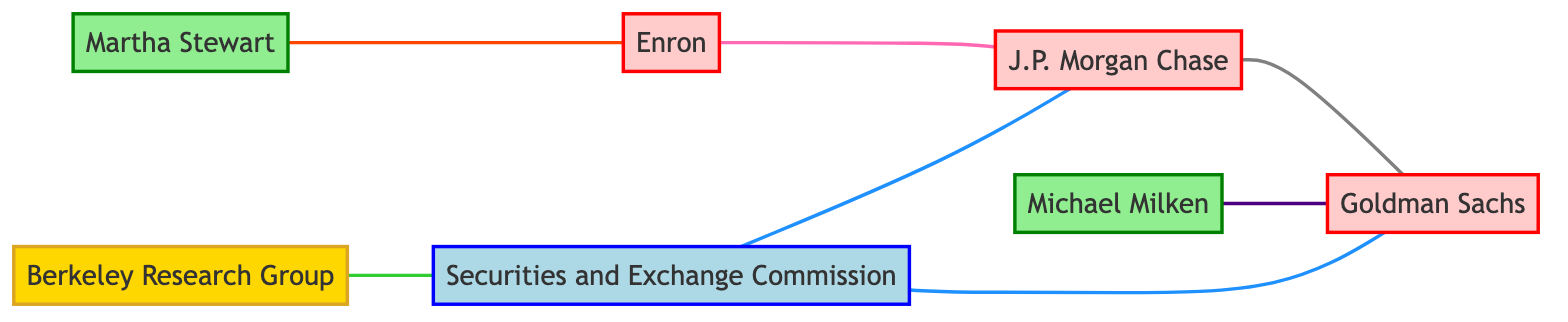What are the total number of nodes in the diagram? The nodes are entities such as corporations, individuals, government agencies, and consulting firms. By counting them from the provided data, we find there are 7 nodes: J.P. Morgan Chase, Goldman Sachs, Enron, Martha Stewart, Michael Milken, SEC, and Berkeley Research Group.
Answer: 7 What type of relationship exists between J.P. Morgan Chase and Goldman Sachs? The edge connecting J.P. Morgan Chase and Goldman Sachs is labeled "Competitors/Collaborators," indicating their relationship context.
Answer: Competitors/Collaborators Who is connected to Enron through stock manipulation? The edge between Martha Stewart and Enron indicates that Martha Stewart is involved in a stock manipulation case related to Enron. Therefore, she is the individual connected through this specific activity.
Answer: Martha Stewart How many edges involve the SEC? There are three edges connected to the SEC, which include regulatory oversight over J.P. Morgan Chase, regulatory oversight over Goldman Sachs, and expert consultation with Berkeley Research Group. Thus, the total is counted as three.
Answer: 3 Which individual is associated with insider trading investigation related to Goldman Sachs? By examining the edge connecting Michael Milken to Goldman Sachs labeled "Insider Trading Investigation," we conclude that Michael Milken is the individual involved with this investigation.
Answer: Michael Milken Which corporation is loan provider to J.P. Morgan Chase? Observing the edge between Enron and J.P. Morgan Chase, labeled "Loan Provider," we can determine that Enron is the corporation providing loans to J.P. Morgan Chase.
Answer: Enron What consulting firm is connected to the SEC? The edge labeled "Expert Consultation" connects Berkeley Research Group to the SEC, indicating that this consulting firm is involved in the relationship with the SEC.
Answer: Berkeley Research Group How many total edges are depicted in the diagram? The edges represent relationships between the different nodes. By counting the relationships provided in the data, there are 6 edges in total connecting various entities.
Answer: 6 What is the label of the edge connecting SEC and J.P. Morgan Chase? The edge connecting SEC to J.P. Morgan Chase is labeled "Regulatory Oversight," specifying the nature of their relationship.
Answer: Regulatory Oversight 